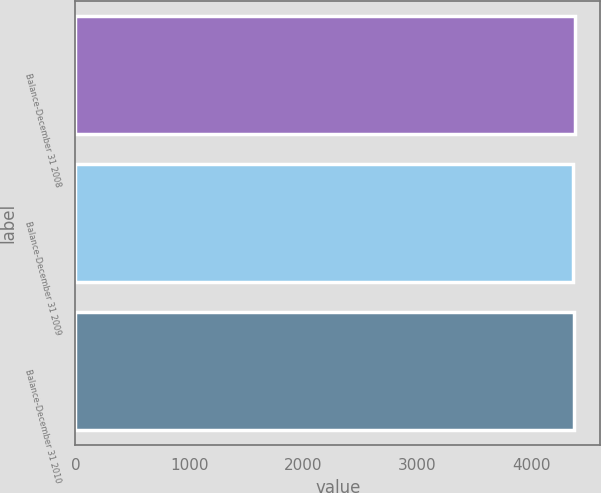<chart> <loc_0><loc_0><loc_500><loc_500><bar_chart><fcel>Balance-December 31 2008<fcel>Balance-December 31 2009<fcel>Balance-December 31 2010<nl><fcel>4387<fcel>4371<fcel>4377<nl></chart> 